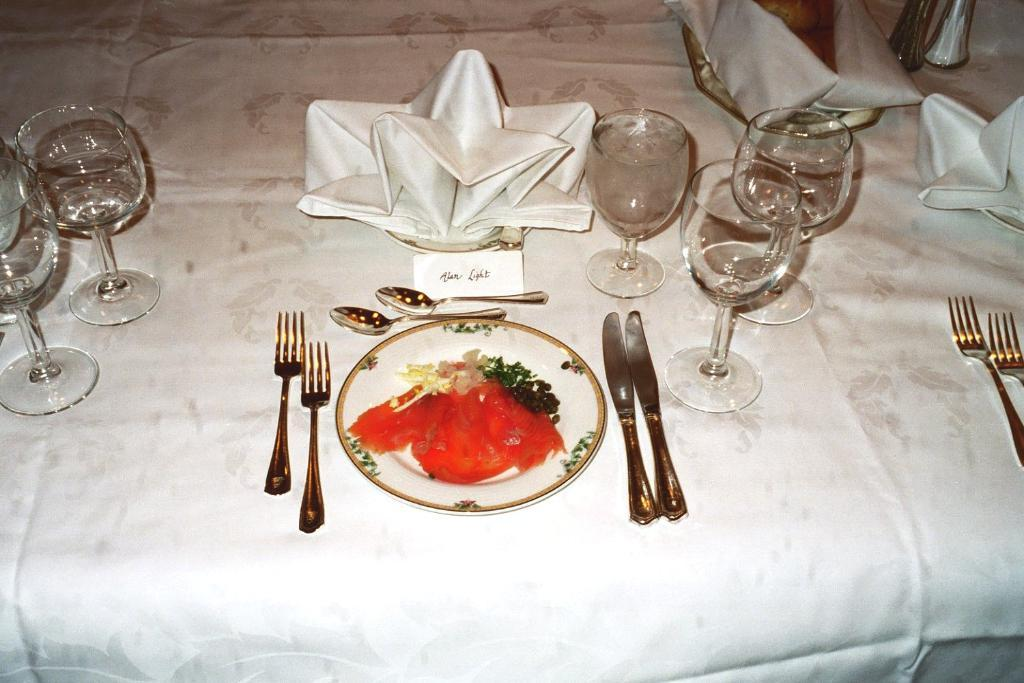What type of furniture is present in the image? There is a table in the image. What items can be seen on the table? The table has glasses, spoons, forks, plates, and tissues on it. How is the table decorated or covered? The table is covered with a cloth. What type of pickle is stored in the crate on the table? There is no crate or pickle present in the image. What color is the skin of the person sitting at the table? There is no person sitting at the table in the image. 